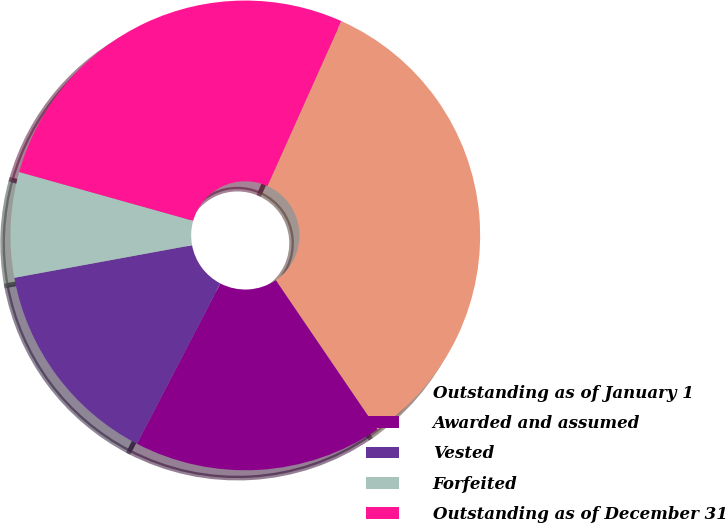Convert chart to OTSL. <chart><loc_0><loc_0><loc_500><loc_500><pie_chart><fcel>Outstanding as of January 1<fcel>Awarded and assumed<fcel>Vested<fcel>Forfeited<fcel>Outstanding as of December 31<nl><fcel>33.79%<fcel>17.14%<fcel>14.48%<fcel>7.24%<fcel>27.35%<nl></chart> 